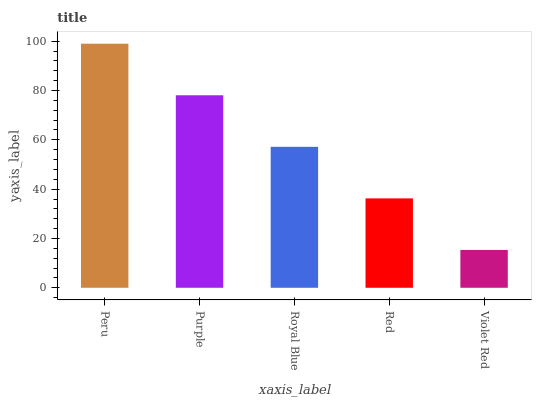Is Purple the minimum?
Answer yes or no. No. Is Purple the maximum?
Answer yes or no. No. Is Peru greater than Purple?
Answer yes or no. Yes. Is Purple less than Peru?
Answer yes or no. Yes. Is Purple greater than Peru?
Answer yes or no. No. Is Peru less than Purple?
Answer yes or no. No. Is Royal Blue the high median?
Answer yes or no. Yes. Is Royal Blue the low median?
Answer yes or no. Yes. Is Violet Red the high median?
Answer yes or no. No. Is Red the low median?
Answer yes or no. No. 